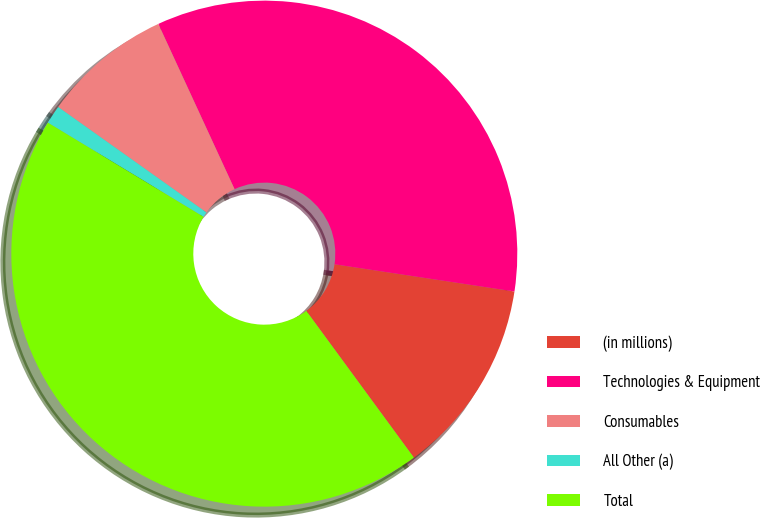Convert chart to OTSL. <chart><loc_0><loc_0><loc_500><loc_500><pie_chart><fcel>(in millions)<fcel>Technologies & Equipment<fcel>Consumables<fcel>All Other (a)<fcel>Total<nl><fcel>12.54%<fcel>34.27%<fcel>8.28%<fcel>1.18%<fcel>43.73%<nl></chart> 